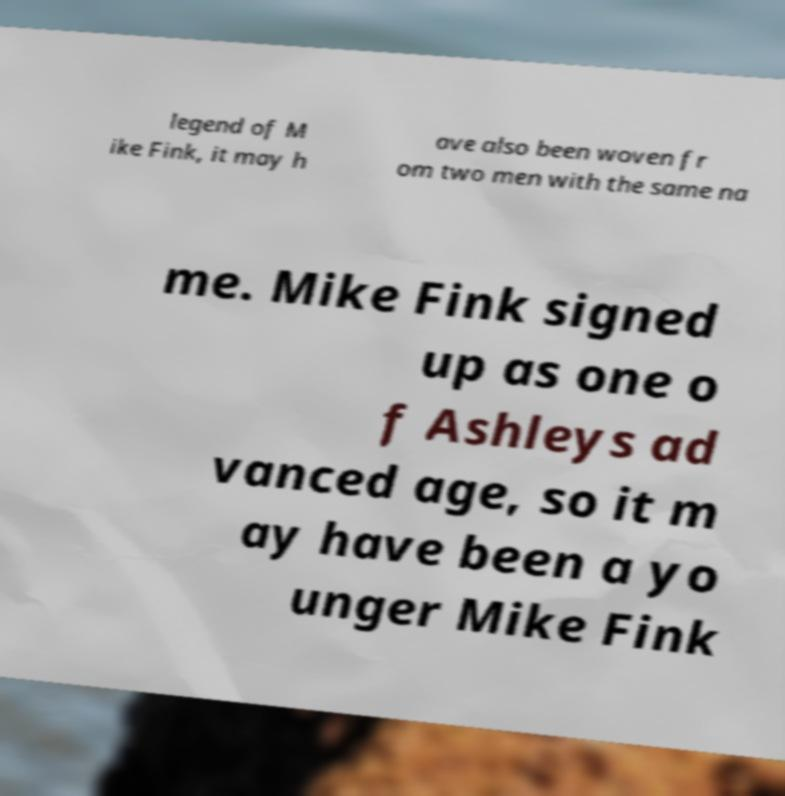Could you extract and type out the text from this image? legend of M ike Fink, it may h ave also been woven fr om two men with the same na me. Mike Fink signed up as one o f Ashleys ad vanced age, so it m ay have been a yo unger Mike Fink 